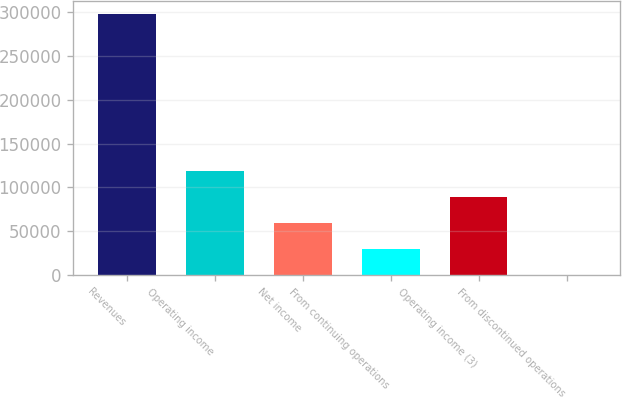<chart> <loc_0><loc_0><loc_500><loc_500><bar_chart><fcel>Revenues<fcel>Operating income<fcel>Net income<fcel>From continuing operations<fcel>Operating income (3)<fcel>From discontinued operations<nl><fcel>297706<fcel>119082<fcel>59541.2<fcel>29770.6<fcel>89311.8<fcel>0.01<nl></chart> 